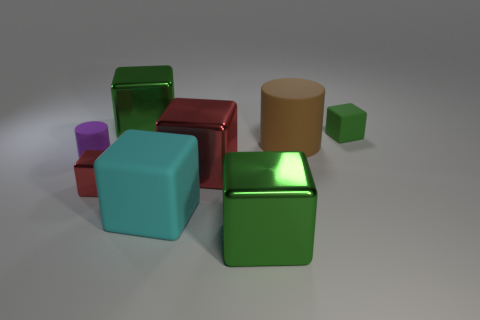There is a thing that is the same color as the tiny shiny cube; what size is it?
Your response must be concise. Large. How many large blocks are behind the green shiny object that is behind the large green shiny block in front of the tiny red cube?
Your answer should be compact. 0. Do the large cylinder and the tiny cylinder have the same color?
Make the answer very short. No. Are there any tiny shiny cubes of the same color as the big matte block?
Offer a terse response. No. There is another matte object that is the same size as the cyan object; what color is it?
Offer a terse response. Brown. Are there any tiny green rubber things that have the same shape as the large red thing?
Provide a succinct answer. Yes. There is another object that is the same color as the tiny metallic object; what is its shape?
Provide a succinct answer. Cube. There is a red metallic object that is on the left side of the green metal cube that is behind the tiny purple matte thing; are there any green shiny things that are in front of it?
Your response must be concise. Yes. There is a red metallic object that is the same size as the green rubber thing; what is its shape?
Give a very brief answer. Cube. What is the color of the other rubber object that is the same shape as the cyan thing?
Give a very brief answer. Green. 